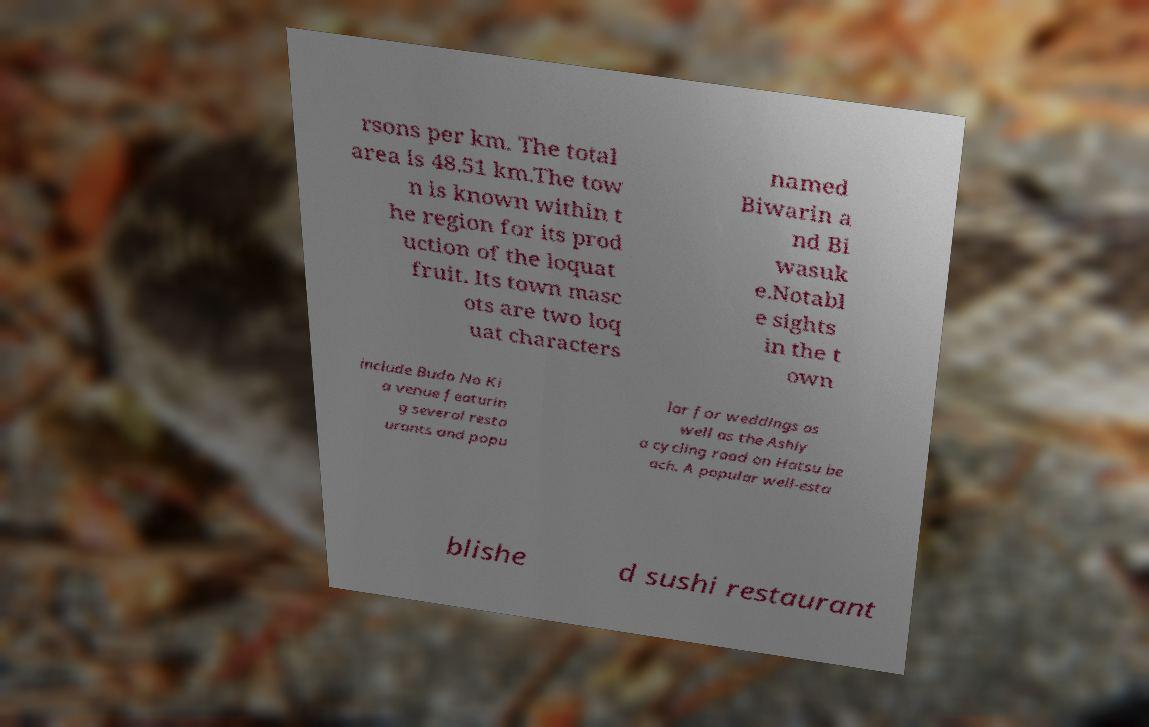Please identify and transcribe the text found in this image. rsons per km. The total area is 48.51 km.The tow n is known within t he region for its prod uction of the loquat fruit. Its town masc ots are two loq uat characters named Biwarin a nd Bi wasuk e.Notabl e sights in the t own include Budo No Ki a venue featurin g several resta urants and popu lar for weddings as well as the Ashiy a cycling road on Hatsu be ach. A popular well-esta blishe d sushi restaurant 